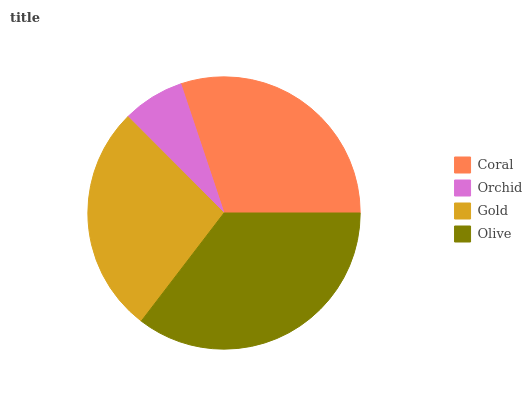Is Orchid the minimum?
Answer yes or no. Yes. Is Olive the maximum?
Answer yes or no. Yes. Is Gold the minimum?
Answer yes or no. No. Is Gold the maximum?
Answer yes or no. No. Is Gold greater than Orchid?
Answer yes or no. Yes. Is Orchid less than Gold?
Answer yes or no. Yes. Is Orchid greater than Gold?
Answer yes or no. No. Is Gold less than Orchid?
Answer yes or no. No. Is Coral the high median?
Answer yes or no. Yes. Is Gold the low median?
Answer yes or no. Yes. Is Gold the high median?
Answer yes or no. No. Is Olive the low median?
Answer yes or no. No. 